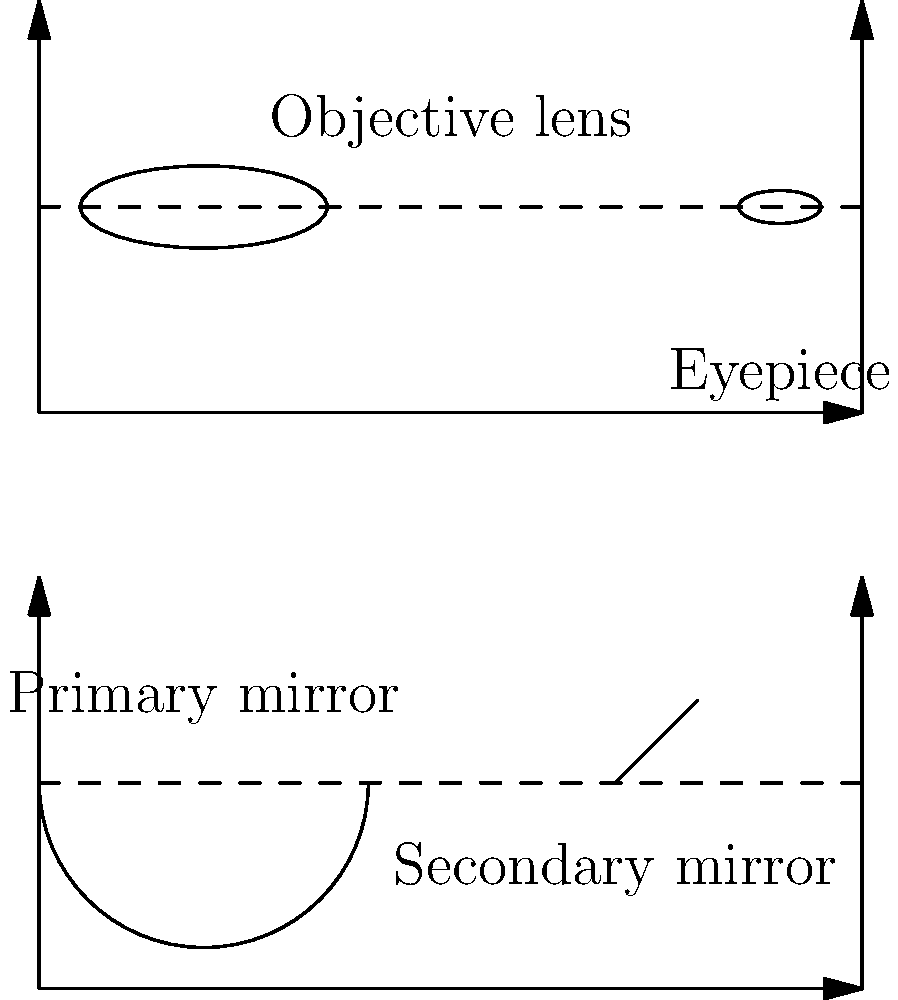The diagram shows simplified schematics of two types of telescopes. Which type of telescope uses mirrors instead of lenses to gather and focus light, and how does this design potentially benefit research on personalized drug responses? 1. The diagram shows two types of telescopes:
   a) The upper diagram represents a refracting telescope, which uses lenses.
   b) The lower diagram represents a reflecting telescope, which uses mirrors.

2. The reflecting telescope (lower diagram) uses mirrors instead of lenses to gather and focus light.

3. Benefits of reflecting telescopes for research on personalized drug responses:
   a) Larger apertures: Reflecting telescopes can have much larger primary mirrors than refracting telescopes' lenses, allowing for more light collection.
   b) Better image quality: Mirrors don't suffer from chromatic aberration, providing clearer images.
   c) Cost-effective for large sizes: Easier and cheaper to produce large mirrors than large lenses.

4. Relevance to personalized medicine research:
   a) Improved spectroscopy: Better light collection and image quality allow for more detailed spectroscopic analysis of celestial objects, which can be analogous to analyzing complex biological samples.
   b) Precision: The ability to detect faint signals and subtle differences in light spectra relates to identifying small genetic variations that influence drug responses.
   c) Big data handling: Large reflecting telescopes generate vast amounts of data, similar to genomic studies in personalized medicine, requiring advanced data processing techniques.

5. Connection to the research participant's perspective:
   Understanding how advanced instruments like reflecting telescopes improve data collection and analysis can help appreciate the complexity and precision required in studying individual genetic makeup for personalized drug responses.
Answer: Reflecting telescope; larger aperture for more data, better image quality for precision, cost-effective scaling for extensive studies. 